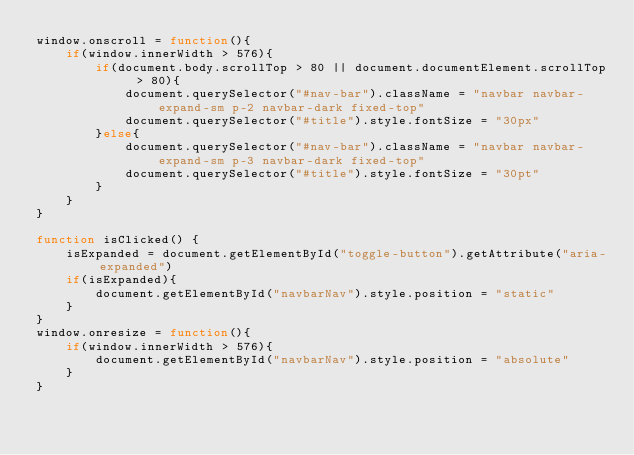<code> <loc_0><loc_0><loc_500><loc_500><_JavaScript_>window.onscroll = function(){
    if(window.innerWidth > 576){
        if(document.body.scrollTop > 80 || document.documentElement.scrollTop > 80){
            document.querySelector("#nav-bar").className = "navbar navbar-expand-sm p-2 navbar-dark fixed-top"
            document.querySelector("#title").style.fontSize = "30px"
        }else{
            document.querySelector("#nav-bar").className = "navbar navbar-expand-sm p-3 navbar-dark fixed-top"
            document.querySelector("#title").style.fontSize = "30pt"
        }
    }
}

function isClicked() {
    isExpanded = document.getElementById("toggle-button").getAttribute("aria-expanded")
    if(isExpanded){
        document.getElementById("navbarNav").style.position = "static"
    }
}
window.onresize = function(){
    if(window.innerWidth > 576){
        document.getElementById("navbarNav").style.position = "absolute"
    }
}</code> 